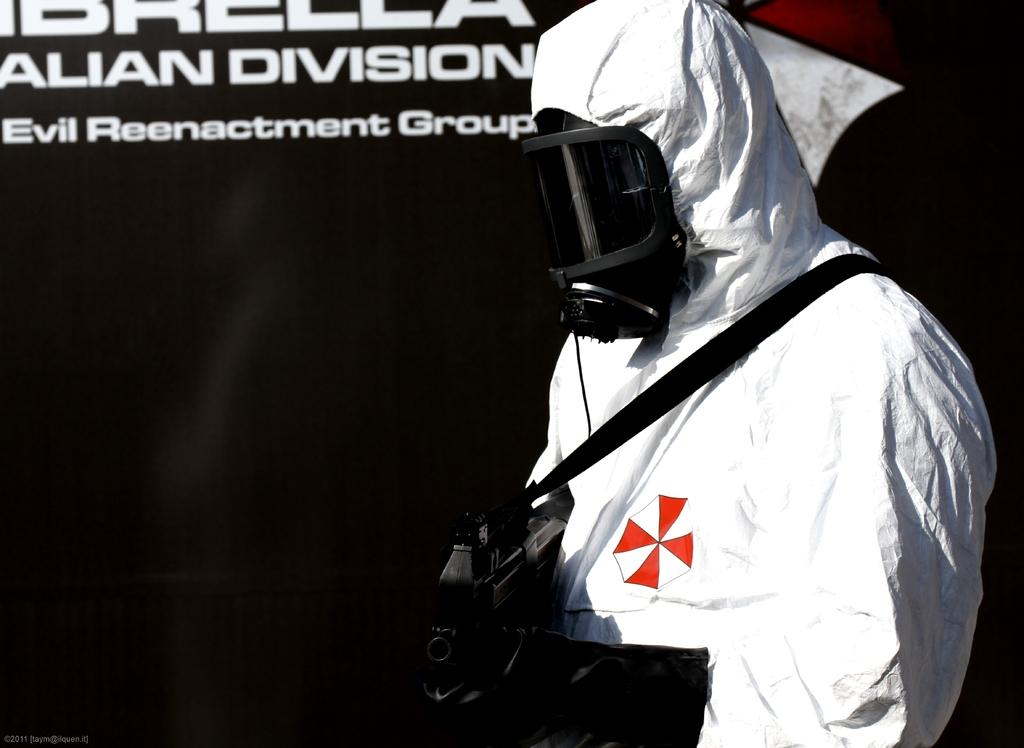What can be seen in the image? There is a person in the image. Can you describe the person's appearance? The person is wearing a mask. What is the person holding in their hand? The person is holding something in their hand, but we cannot determine what it is from the image. What is visible in the background of the image? There is a wall in the background of the image. What is written on the wall? The wall has text on it. What type of bait is the person using in the image? There is no bait present in the image. What kind of pancake is the person eating in the image? There is no pancake present in the image. 